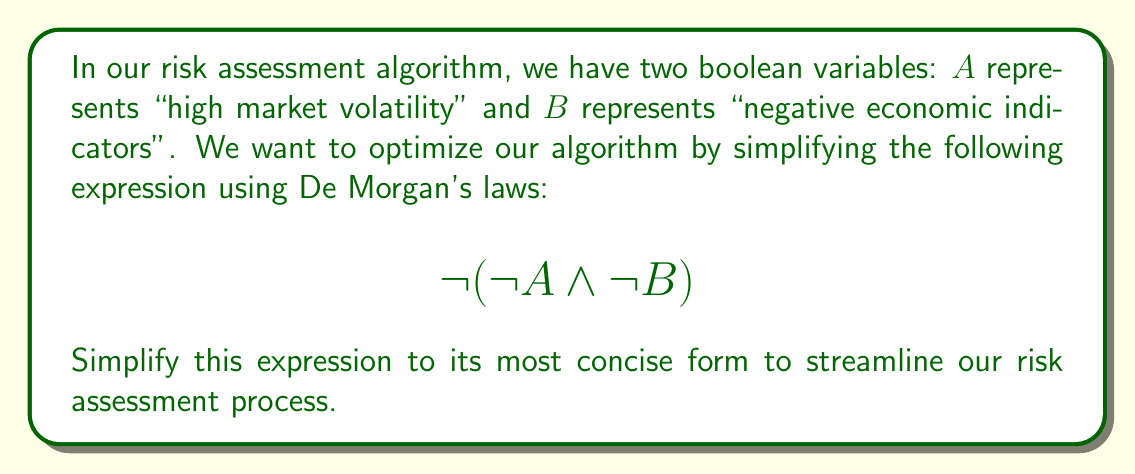Show me your answer to this math problem. Let's apply De Morgan's laws step-by-step to simplify the given expression:

1. We start with the expression: $\neg(\neg A \land \neg B)$

2. De Morgan's law states that the negation of a conjunction is the disjunction of the negations. In other words:
   $\neg(X \land Y) \equiv \neg X \lor \neg Y$

3. Applying this law to our expression:
   $\neg(\neg A \land \neg B) \equiv \neg(\neg A) \lor \neg(\neg B)$

4. Now we can simplify the double negations:
   $\neg(\neg A) \equiv A$
   $\neg(\neg B) \equiv B$

5. Substituting these back into our expression:
   $\neg(\neg A \land \neg B) \equiv A \lor B$

6. This final form, $A \lor B$, is the most simplified version of the original expression.

In the context of our risk assessment, this simplification means that our algorithm will flag a high-risk situation if either there is high market volatility (A) OR there are negative economic indicators (B), which is logically equivalent to the original, more complex expression.
Answer: $A \lor B$ 